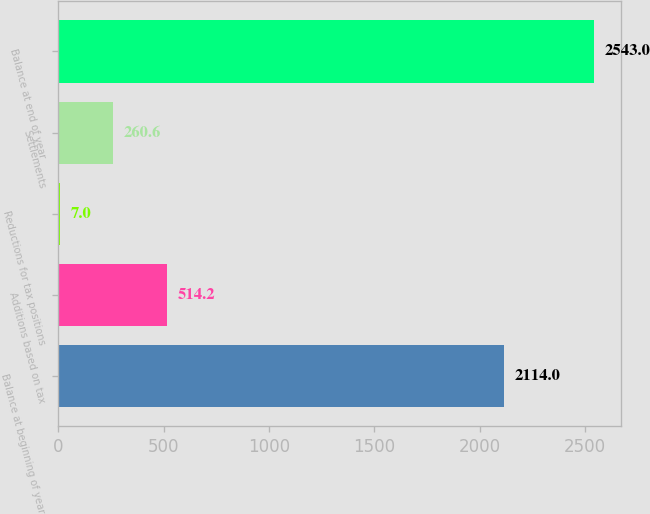Convert chart to OTSL. <chart><loc_0><loc_0><loc_500><loc_500><bar_chart><fcel>Balance at beginning of year<fcel>Additions based on tax<fcel>Reductions for tax positions<fcel>Settlements<fcel>Balance at end of year<nl><fcel>2114<fcel>514.2<fcel>7<fcel>260.6<fcel>2543<nl></chart> 